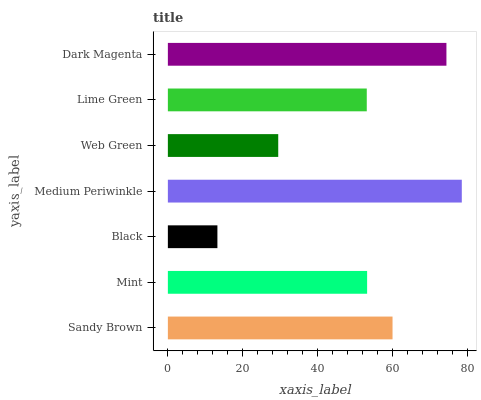Is Black the minimum?
Answer yes or no. Yes. Is Medium Periwinkle the maximum?
Answer yes or no. Yes. Is Mint the minimum?
Answer yes or no. No. Is Mint the maximum?
Answer yes or no. No. Is Sandy Brown greater than Mint?
Answer yes or no. Yes. Is Mint less than Sandy Brown?
Answer yes or no. Yes. Is Mint greater than Sandy Brown?
Answer yes or no. No. Is Sandy Brown less than Mint?
Answer yes or no. No. Is Mint the high median?
Answer yes or no. Yes. Is Mint the low median?
Answer yes or no. Yes. Is Dark Magenta the high median?
Answer yes or no. No. Is Lime Green the low median?
Answer yes or no. No. 